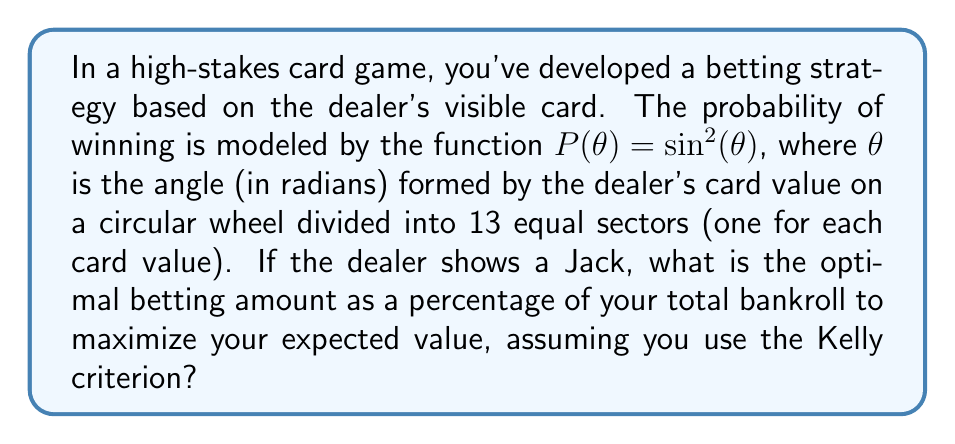Provide a solution to this math problem. To solve this problem, we'll follow these steps:

1) First, we need to determine the angle $\theta$ for a Jack on the circular wheel:
   - There are 13 sectors (2 through Ace), each covering $\frac{2\pi}{13}$ radians
   - Jack is the 11th card, so its angle is: $\theta = \frac{11 \cdot 2\pi}{13}$ radians

2) Calculate the probability of winning using the given function:
   $P(\theta) = \sin^2(\frac{11 \cdot 2\pi}{13})$

3) The Kelly criterion for optimal bet size is given by:
   $f^* = p - \frac{q}{b}$
   where:
   $f^*$ is the fraction of the bankroll to bet
   $p$ is the probability of winning
   $q = 1-p$ is the probability of losing
   $b$ is the net odds received on the bet (usually 1 for even money bets)

4) Calculate $p$ and $q$:
   $p = \sin^2(\frac{11 \cdot 2\pi}{13}) \approx 0.7528$
   $q = 1 - p \approx 0.2472$

5) Assuming even money bets ($b=1$), apply the Kelly criterion:
   $f^* = p - q = 2p - 1 = 2 \sin^2(\frac{11 \cdot 2\pi}{13}) - 1$

6) Calculate the final result:
   $f^* = 2 \cdot 0.7528 - 1 \approx 0.5056$

7) Convert to a percentage:
   $0.5056 \cdot 100\% \approx 50.56\%$
Answer: The optimal betting amount is approximately 50.56% of your total bankroll. 